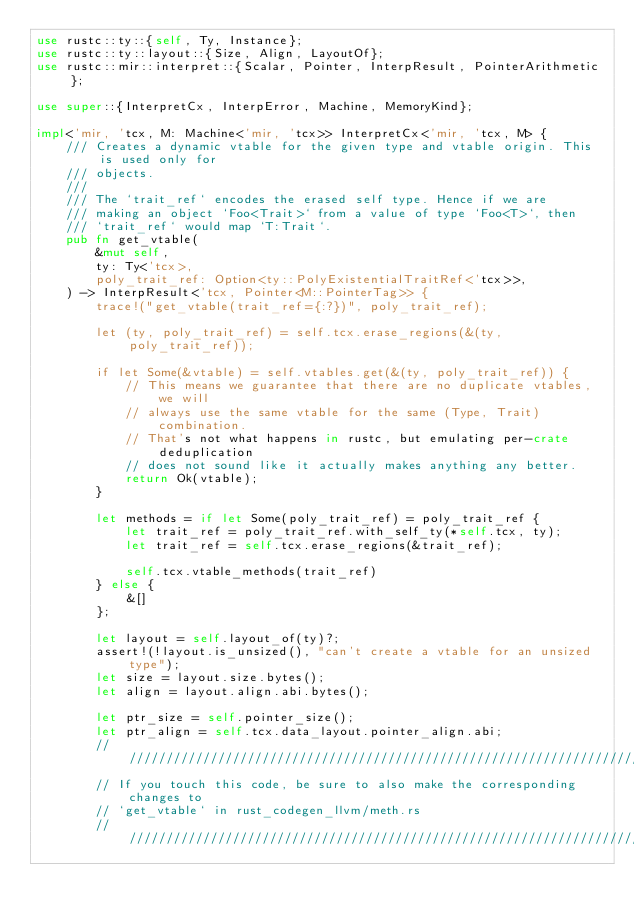Convert code to text. <code><loc_0><loc_0><loc_500><loc_500><_Rust_>use rustc::ty::{self, Ty, Instance};
use rustc::ty::layout::{Size, Align, LayoutOf};
use rustc::mir::interpret::{Scalar, Pointer, InterpResult, PointerArithmetic};

use super::{InterpretCx, InterpError, Machine, MemoryKind};

impl<'mir, 'tcx, M: Machine<'mir, 'tcx>> InterpretCx<'mir, 'tcx, M> {
    /// Creates a dynamic vtable for the given type and vtable origin. This is used only for
    /// objects.
    ///
    /// The `trait_ref` encodes the erased self type. Hence if we are
    /// making an object `Foo<Trait>` from a value of type `Foo<T>`, then
    /// `trait_ref` would map `T:Trait`.
    pub fn get_vtable(
        &mut self,
        ty: Ty<'tcx>,
        poly_trait_ref: Option<ty::PolyExistentialTraitRef<'tcx>>,
    ) -> InterpResult<'tcx, Pointer<M::PointerTag>> {
        trace!("get_vtable(trait_ref={:?})", poly_trait_ref);

        let (ty, poly_trait_ref) = self.tcx.erase_regions(&(ty, poly_trait_ref));

        if let Some(&vtable) = self.vtables.get(&(ty, poly_trait_ref)) {
            // This means we guarantee that there are no duplicate vtables, we will
            // always use the same vtable for the same (Type, Trait) combination.
            // That's not what happens in rustc, but emulating per-crate deduplication
            // does not sound like it actually makes anything any better.
            return Ok(vtable);
        }

        let methods = if let Some(poly_trait_ref) = poly_trait_ref {
            let trait_ref = poly_trait_ref.with_self_ty(*self.tcx, ty);
            let trait_ref = self.tcx.erase_regions(&trait_ref);

            self.tcx.vtable_methods(trait_ref)
        } else {
            &[]
        };

        let layout = self.layout_of(ty)?;
        assert!(!layout.is_unsized(), "can't create a vtable for an unsized type");
        let size = layout.size.bytes();
        let align = layout.align.abi.bytes();

        let ptr_size = self.pointer_size();
        let ptr_align = self.tcx.data_layout.pointer_align.abi;
        // /////////////////////////////////////////////////////////////////////////////////////////
        // If you touch this code, be sure to also make the corresponding changes to
        // `get_vtable` in rust_codegen_llvm/meth.rs
        // /////////////////////////////////////////////////////////////////////////////////////////</code> 